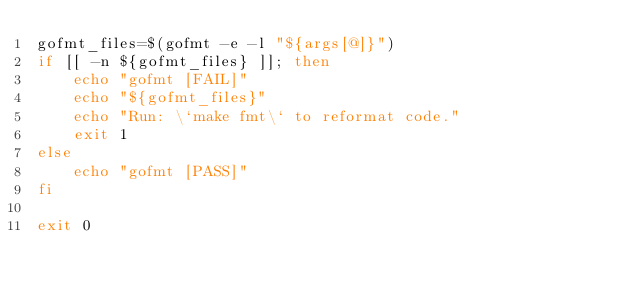<code> <loc_0><loc_0><loc_500><loc_500><_Bash_>gofmt_files=$(gofmt -e -l "${args[@]}")
if [[ -n ${gofmt_files} ]]; then
    echo "gofmt [FAIL]"
    echo "${gofmt_files}"
    echo "Run: \`make fmt\` to reformat code."
    exit 1
else
    echo "gofmt [PASS]"
fi

exit 0
</code> 